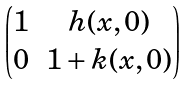<formula> <loc_0><loc_0><loc_500><loc_500>\begin{pmatrix} 1 & h ( x , 0 ) \\ 0 & 1 + k ( x , 0 ) \end{pmatrix}</formula> 